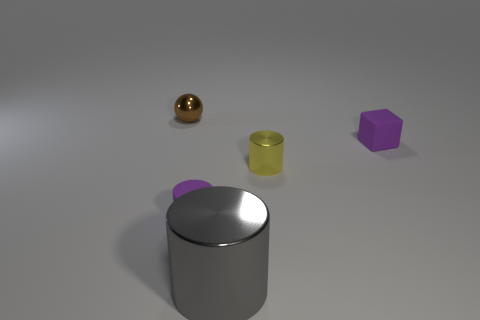Does the small matte cube have the same color as the matte cylinder?
Make the answer very short. Yes. Does the big metallic thing have the same shape as the purple object that is left of the tiny metallic cylinder?
Keep it short and to the point. Yes. There is a tiny purple thing that is in front of the rubber cube; is it the same shape as the yellow metallic object?
Your answer should be very brief. Yes. There is a thing that is the same color as the tiny matte cylinder; what is its shape?
Keep it short and to the point. Cube. Are there the same number of tiny metallic things that are in front of the tiny purple matte cube and small balls?
Offer a terse response. Yes. What is the size of the matte object that is the same color as the matte cylinder?
Your answer should be compact. Small. Does the small yellow metallic object have the same shape as the large shiny object?
Ensure brevity in your answer.  Yes. What number of objects are either purple matte objects that are in front of the tiny matte cube or purple matte blocks?
Make the answer very short. 2. Are there the same number of objects to the right of the big metal cylinder and large gray cylinders that are right of the small yellow metal object?
Offer a terse response. No. How many other objects are there of the same shape as the tiny brown metallic thing?
Provide a succinct answer. 0. 